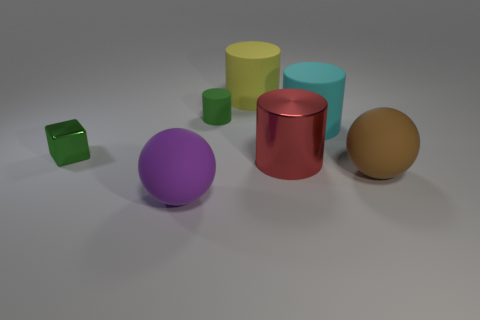Add 1 large matte objects. How many objects exist? 8 Subtract all balls. How many objects are left? 5 Add 6 balls. How many balls are left? 8 Add 4 tiny green metallic things. How many tiny green metallic things exist? 5 Subtract 0 gray cubes. How many objects are left? 7 Subtract all green matte cylinders. Subtract all small shiny objects. How many objects are left? 5 